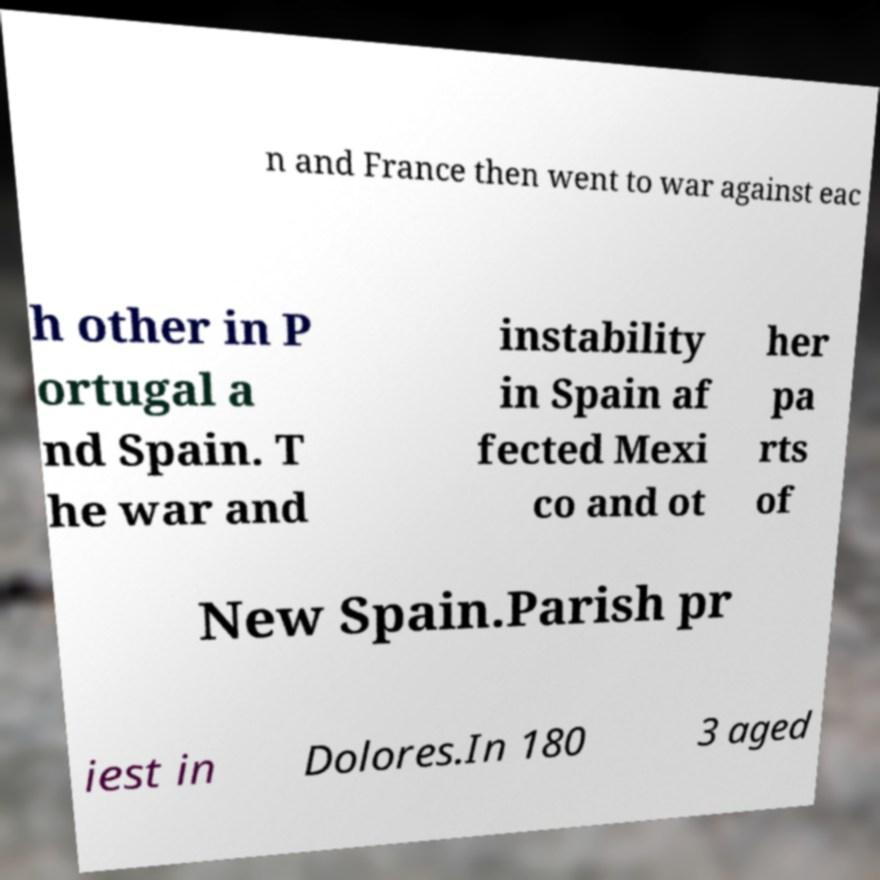Can you accurately transcribe the text from the provided image for me? n and France then went to war against eac h other in P ortugal a nd Spain. T he war and instability in Spain af fected Mexi co and ot her pa rts of New Spain.Parish pr iest in Dolores.In 180 3 aged 